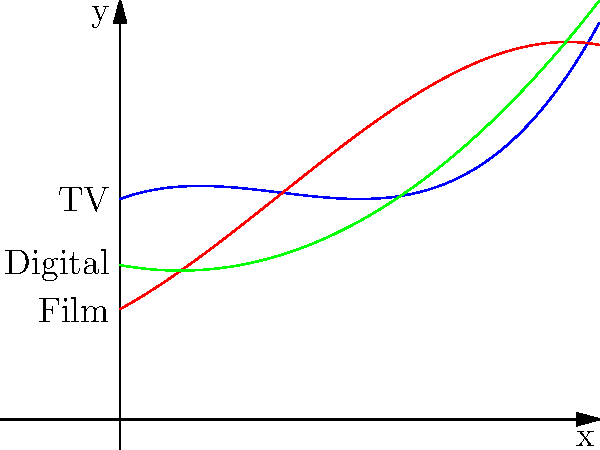The graph shows polynomial functions representing the percentage of diverse demographic representation in different media types over time (x-axis, in years). Function $f(x)$ represents TV, $g(x)$ represents film, and $h(x)$ represents digital media. Which media type is projected to have the highest percentage of diverse representation after 4 years, and what is the difference between the highest and lowest percentages at that point? To solve this problem, we need to follow these steps:

1. Evaluate each function at x = 4 to determine the percentage of diverse representation for each media type after 4 years:

   $f(4) = 0.5(4)^3 - 2(4)^2 + 2(4) + 10 = 32 - 32 + 8 + 10 = 18$
   $g(4) = -0.25(4)^3 + (4)^2 + 3(4) + 5 = -16 + 16 + 12 + 5 = 17$
   $h(4) = (4)^2 - 4 + 7 = 16 - 4 + 7 = 19$

2. Compare the values to determine which media type has the highest percentage:
   TV (f): 18%
   Film (g): 17%
   Digital (h): 19%

   Digital media (h) has the highest percentage at 19%.

3. Calculate the difference between the highest and lowest percentages:
   Highest (Digital): 19%
   Lowest (Film): 17%
   
   Difference: 19% - 17% = 2%

Therefore, digital media is projected to have the highest percentage of diverse representation after 4 years, and the difference between the highest (digital) and lowest (film) percentages is 2%.
Answer: Digital media; 2% 